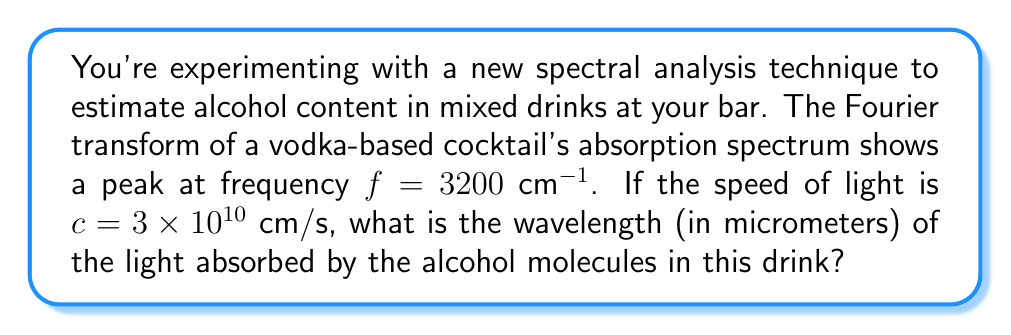Show me your answer to this math problem. To solve this problem, we'll use the relationship between frequency, wavelength, and the speed of light. The steps are as follows:

1) The general equation relating these quantities is:

   $$ c = f \lambda $$

   where $c$ is the speed of light, $f$ is the frequency, and $\lambda$ is the wavelength.

2) We're given the frequency in wavenumbers (cm$^{-1}$), which is the reciprocal of the wavelength in cm. Let's call this $\tilde{\nu}$:

   $$ \tilde{\nu} = 3200 \text{ cm}^{-1} = \frac{1}{\lambda \text{ (in cm)}} $$

3) We can rewrite our equation as:

   $$ c = f\lambda = \frac{c}{\lambda} \lambda = c\tilde{\nu} $$

4) Rearranging to solve for $\lambda$:

   $$ \lambda = \frac{1}{\tilde{\nu}} $$

5) Plugging in our value for $\tilde{\nu}$:

   $$ \lambda = \frac{1}{3200 \text{ cm}^{-1}} = 3.125 \times 10^{-4} \text{ cm} $$

6) Converting to micrometers:

   $$ \lambda = 3.125 \times 10^{-4} \text{ cm} \times \frac{10^4 \text{ μm}}{1 \text{ cm}} = 3.125 \text{ μm} $$

Therefore, the wavelength of the light absorbed by the alcohol molecules is 3.125 micrometers.
Answer: 3.125 μm 